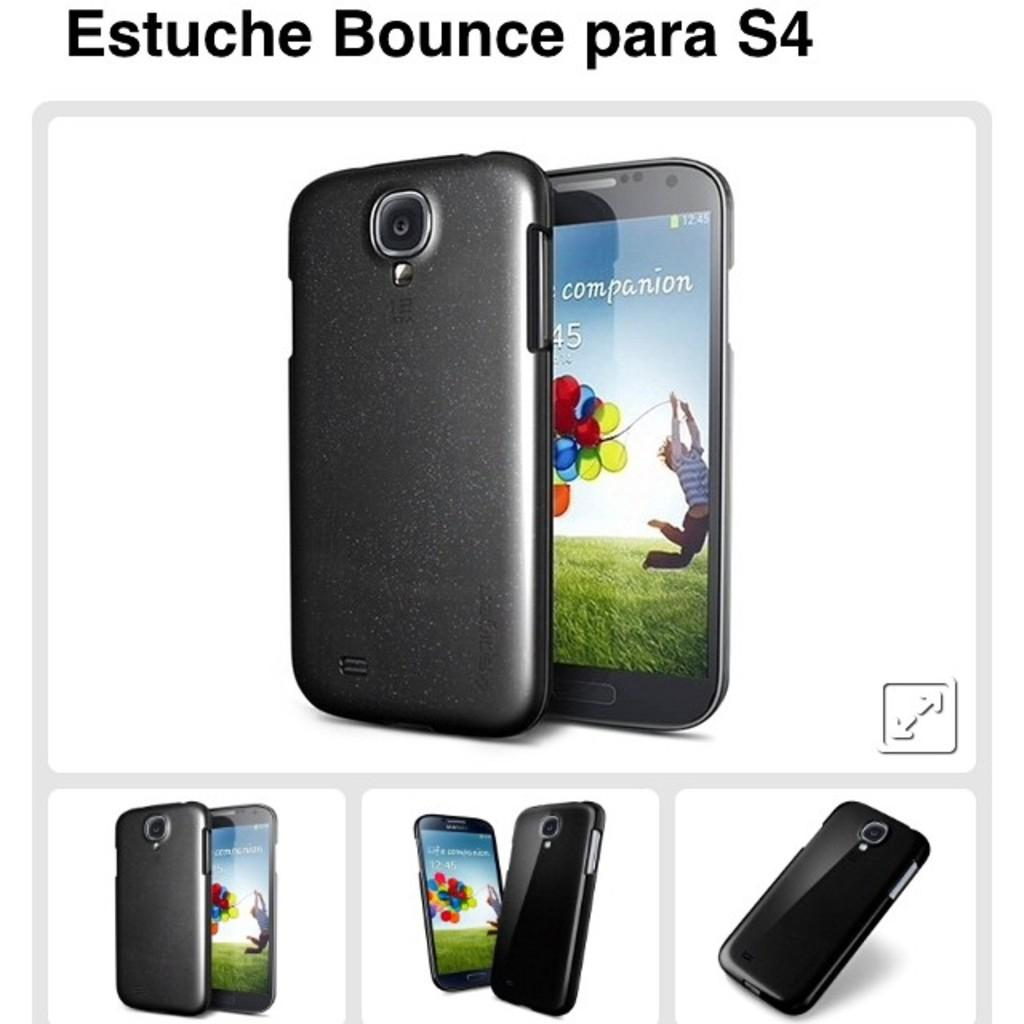<image>
Render a clear and concise summary of the photo. Different views of a phone that displays a time of 12:45. 